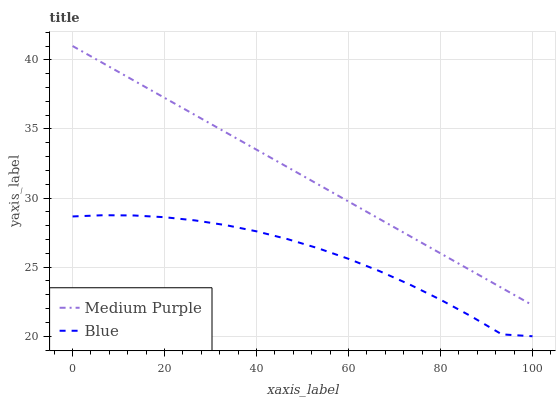Does Blue have the minimum area under the curve?
Answer yes or no. Yes. Does Medium Purple have the maximum area under the curve?
Answer yes or no. Yes. Does Blue have the maximum area under the curve?
Answer yes or no. No. Is Medium Purple the smoothest?
Answer yes or no. Yes. Is Blue the roughest?
Answer yes or no. Yes. Is Blue the smoothest?
Answer yes or no. No. Does Medium Purple have the highest value?
Answer yes or no. Yes. Does Blue have the highest value?
Answer yes or no. No. Is Blue less than Medium Purple?
Answer yes or no. Yes. Is Medium Purple greater than Blue?
Answer yes or no. Yes. Does Blue intersect Medium Purple?
Answer yes or no. No. 